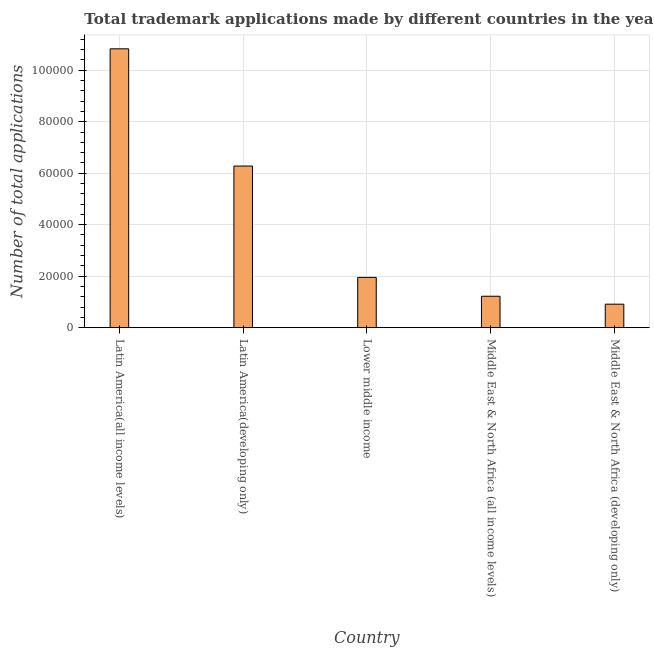Does the graph contain any zero values?
Offer a very short reply. No. Does the graph contain grids?
Make the answer very short. Yes. What is the title of the graph?
Offer a very short reply. Total trademark applications made by different countries in the year 1967. What is the label or title of the X-axis?
Provide a short and direct response. Country. What is the label or title of the Y-axis?
Ensure brevity in your answer.  Number of total applications. What is the number of trademark applications in Middle East & North Africa (all income levels)?
Provide a succinct answer. 1.22e+04. Across all countries, what is the maximum number of trademark applications?
Provide a short and direct response. 1.08e+05. Across all countries, what is the minimum number of trademark applications?
Make the answer very short. 9122. In which country was the number of trademark applications maximum?
Give a very brief answer. Latin America(all income levels). In which country was the number of trademark applications minimum?
Your answer should be very brief. Middle East & North Africa (developing only). What is the sum of the number of trademark applications?
Provide a succinct answer. 2.12e+05. What is the difference between the number of trademark applications in Lower middle income and Middle East & North Africa (developing only)?
Offer a very short reply. 1.04e+04. What is the average number of trademark applications per country?
Ensure brevity in your answer.  4.24e+04. What is the median number of trademark applications?
Provide a succinct answer. 1.95e+04. In how many countries, is the number of trademark applications greater than 4000 ?
Provide a short and direct response. 5. What is the ratio of the number of trademark applications in Lower middle income to that in Middle East & North Africa (all income levels)?
Your response must be concise. 1.6. Is the difference between the number of trademark applications in Latin America(all income levels) and Middle East & North Africa (all income levels) greater than the difference between any two countries?
Keep it short and to the point. No. What is the difference between the highest and the second highest number of trademark applications?
Make the answer very short. 4.55e+04. Is the sum of the number of trademark applications in Latin America(all income levels) and Middle East & North Africa (developing only) greater than the maximum number of trademark applications across all countries?
Give a very brief answer. Yes. What is the difference between the highest and the lowest number of trademark applications?
Give a very brief answer. 9.92e+04. In how many countries, is the number of trademark applications greater than the average number of trademark applications taken over all countries?
Your answer should be very brief. 2. How many bars are there?
Make the answer very short. 5. What is the difference between two consecutive major ticks on the Y-axis?
Offer a terse response. 2.00e+04. What is the Number of total applications in Latin America(all income levels)?
Your answer should be very brief. 1.08e+05. What is the Number of total applications in Latin America(developing only)?
Your answer should be very brief. 6.28e+04. What is the Number of total applications of Lower middle income?
Provide a short and direct response. 1.95e+04. What is the Number of total applications in Middle East & North Africa (all income levels)?
Your response must be concise. 1.22e+04. What is the Number of total applications of Middle East & North Africa (developing only)?
Provide a short and direct response. 9122. What is the difference between the Number of total applications in Latin America(all income levels) and Latin America(developing only)?
Your answer should be very brief. 4.55e+04. What is the difference between the Number of total applications in Latin America(all income levels) and Lower middle income?
Provide a short and direct response. 8.88e+04. What is the difference between the Number of total applications in Latin America(all income levels) and Middle East & North Africa (all income levels)?
Provide a succinct answer. 9.61e+04. What is the difference between the Number of total applications in Latin America(all income levels) and Middle East & North Africa (developing only)?
Provide a succinct answer. 9.92e+04. What is the difference between the Number of total applications in Latin America(developing only) and Lower middle income?
Your answer should be compact. 4.33e+04. What is the difference between the Number of total applications in Latin America(developing only) and Middle East & North Africa (all income levels)?
Offer a very short reply. 5.06e+04. What is the difference between the Number of total applications in Latin America(developing only) and Middle East & North Africa (developing only)?
Give a very brief answer. 5.37e+04. What is the difference between the Number of total applications in Lower middle income and Middle East & North Africa (all income levels)?
Ensure brevity in your answer.  7320. What is the difference between the Number of total applications in Lower middle income and Middle East & North Africa (developing only)?
Provide a short and direct response. 1.04e+04. What is the difference between the Number of total applications in Middle East & North Africa (all income levels) and Middle East & North Africa (developing only)?
Offer a terse response. 3085. What is the ratio of the Number of total applications in Latin America(all income levels) to that in Latin America(developing only)?
Offer a very short reply. 1.73. What is the ratio of the Number of total applications in Latin America(all income levels) to that in Lower middle income?
Keep it short and to the point. 5.55. What is the ratio of the Number of total applications in Latin America(all income levels) to that in Middle East & North Africa (all income levels)?
Offer a very short reply. 8.87. What is the ratio of the Number of total applications in Latin America(all income levels) to that in Middle East & North Africa (developing only)?
Make the answer very short. 11.88. What is the ratio of the Number of total applications in Latin America(developing only) to that in Lower middle income?
Your answer should be compact. 3.21. What is the ratio of the Number of total applications in Latin America(developing only) to that in Middle East & North Africa (all income levels)?
Provide a succinct answer. 5.14. What is the ratio of the Number of total applications in Latin America(developing only) to that in Middle East & North Africa (developing only)?
Ensure brevity in your answer.  6.88. What is the ratio of the Number of total applications in Lower middle income to that in Middle East & North Africa (all income levels)?
Your answer should be very brief. 1.6. What is the ratio of the Number of total applications in Lower middle income to that in Middle East & North Africa (developing only)?
Provide a succinct answer. 2.14. What is the ratio of the Number of total applications in Middle East & North Africa (all income levels) to that in Middle East & North Africa (developing only)?
Your answer should be very brief. 1.34. 